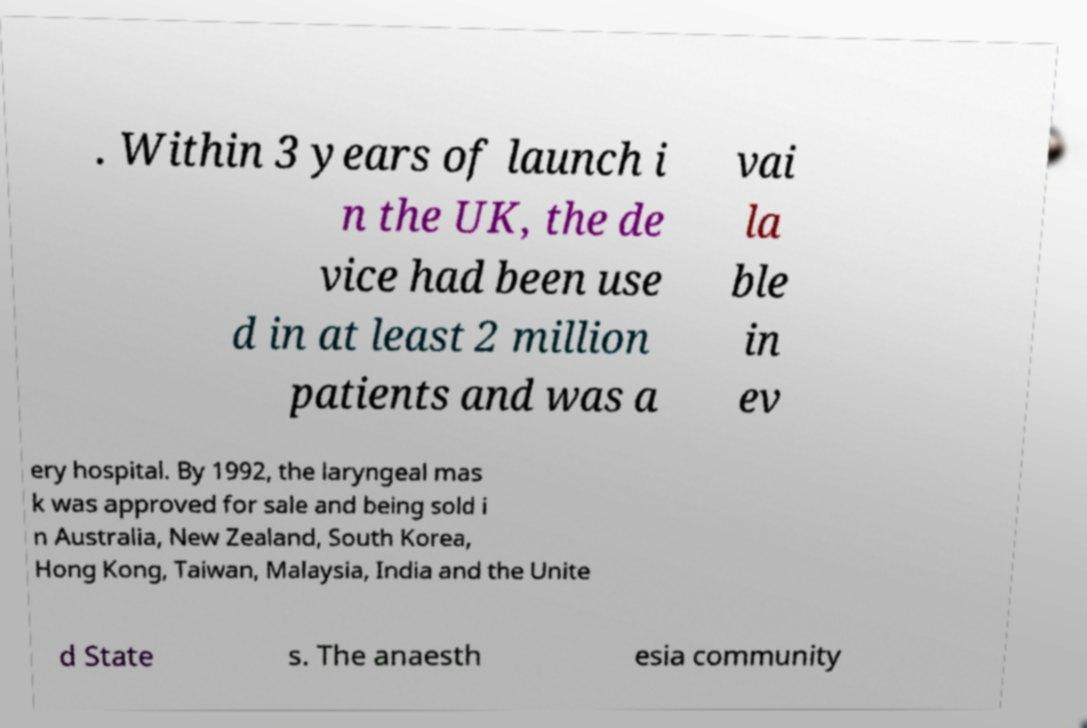There's text embedded in this image that I need extracted. Can you transcribe it verbatim? . Within 3 years of launch i n the UK, the de vice had been use d in at least 2 million patients and was a vai la ble in ev ery hospital. By 1992, the laryngeal mas k was approved for sale and being sold i n Australia, New Zealand, South Korea, Hong Kong, Taiwan, Malaysia, India and the Unite d State s. The anaesth esia community 